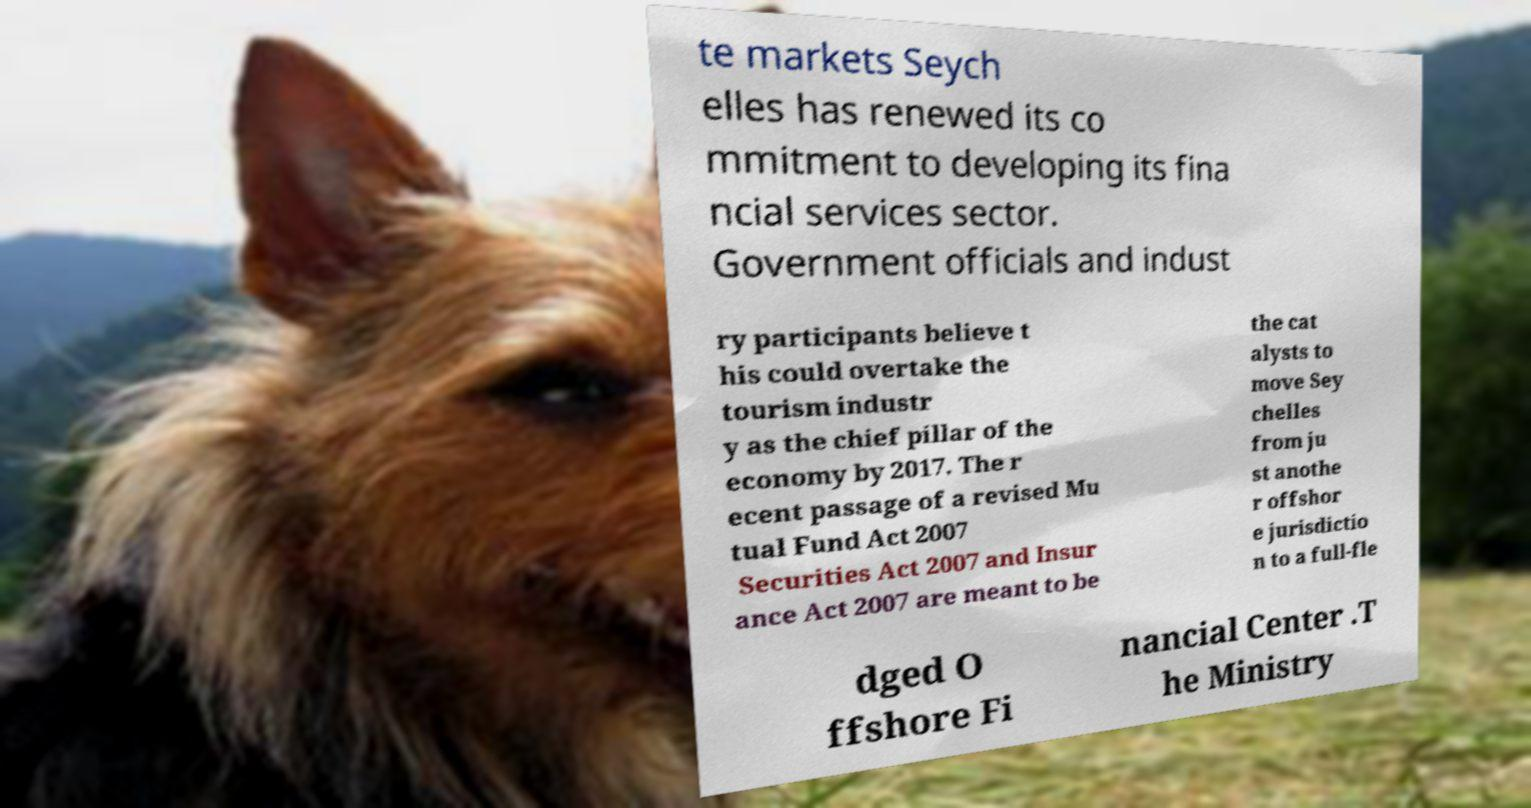I need the written content from this picture converted into text. Can you do that? te markets Seych elles has renewed its co mmitment to developing its fina ncial services sector. Government officials and indust ry participants believe t his could overtake the tourism industr y as the chief pillar of the economy by 2017. The r ecent passage of a revised Mu tual Fund Act 2007 Securities Act 2007 and Insur ance Act 2007 are meant to be the cat alysts to move Sey chelles from ju st anothe r offshor e jurisdictio n to a full-fle dged O ffshore Fi nancial Center .T he Ministry 